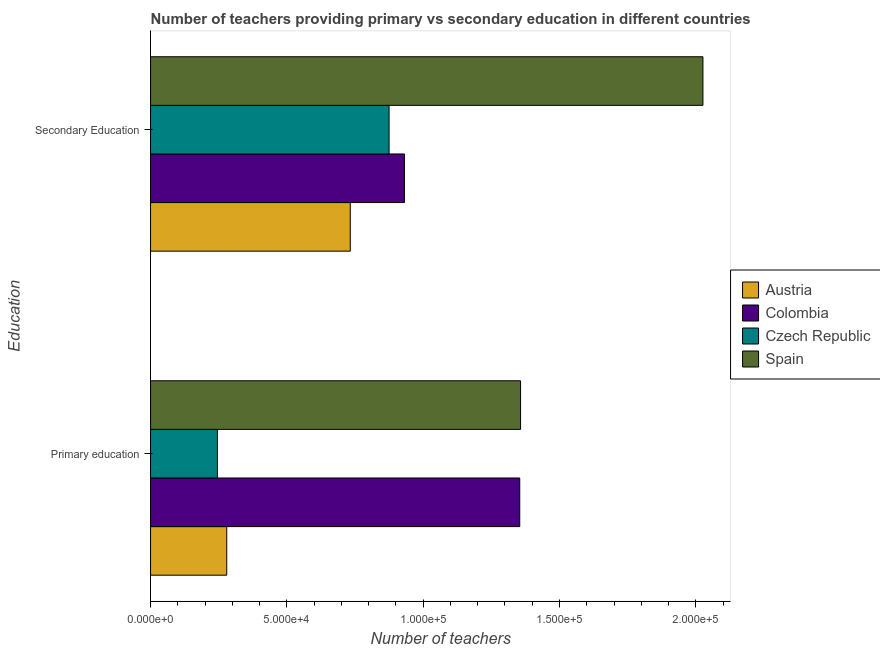How many different coloured bars are there?
Ensure brevity in your answer.  4. How many groups of bars are there?
Your answer should be very brief. 2. Are the number of bars on each tick of the Y-axis equal?
Your answer should be compact. Yes. How many bars are there on the 1st tick from the top?
Provide a succinct answer. 4. What is the number of primary teachers in Spain?
Your answer should be very brief. 1.36e+05. Across all countries, what is the maximum number of primary teachers?
Your answer should be compact. 1.36e+05. Across all countries, what is the minimum number of primary teachers?
Your response must be concise. 2.45e+04. In which country was the number of primary teachers maximum?
Keep it short and to the point. Spain. In which country was the number of secondary teachers minimum?
Offer a very short reply. Austria. What is the total number of secondary teachers in the graph?
Give a very brief answer. 4.56e+05. What is the difference between the number of secondary teachers in Spain and that in Czech Republic?
Ensure brevity in your answer.  1.15e+05. What is the difference between the number of primary teachers in Czech Republic and the number of secondary teachers in Spain?
Provide a succinct answer. -1.78e+05. What is the average number of secondary teachers per country?
Provide a succinct answer. 1.14e+05. What is the difference between the number of secondary teachers and number of primary teachers in Austria?
Ensure brevity in your answer.  4.53e+04. What is the ratio of the number of secondary teachers in Colombia to that in Spain?
Your answer should be very brief. 0.46. Is the number of primary teachers in Colombia less than that in Czech Republic?
Offer a terse response. No. What does the 2nd bar from the top in Secondary Education represents?
Your answer should be very brief. Czech Republic. Are all the bars in the graph horizontal?
Provide a succinct answer. Yes. Are the values on the major ticks of X-axis written in scientific E-notation?
Offer a terse response. Yes. Does the graph contain grids?
Keep it short and to the point. No. Where does the legend appear in the graph?
Your answer should be very brief. Center right. What is the title of the graph?
Provide a short and direct response. Number of teachers providing primary vs secondary education in different countries. Does "Mauritania" appear as one of the legend labels in the graph?
Offer a terse response. No. What is the label or title of the X-axis?
Provide a succinct answer. Number of teachers. What is the label or title of the Y-axis?
Offer a very short reply. Education. What is the Number of teachers in Austria in Primary education?
Your answer should be very brief. 2.79e+04. What is the Number of teachers of Colombia in Primary education?
Your response must be concise. 1.35e+05. What is the Number of teachers of Czech Republic in Primary education?
Make the answer very short. 2.45e+04. What is the Number of teachers in Spain in Primary education?
Ensure brevity in your answer.  1.36e+05. What is the Number of teachers of Austria in Secondary Education?
Ensure brevity in your answer.  7.33e+04. What is the Number of teachers in Colombia in Secondary Education?
Make the answer very short. 9.31e+04. What is the Number of teachers in Czech Republic in Secondary Education?
Your answer should be compact. 8.75e+04. What is the Number of teachers of Spain in Secondary Education?
Offer a very short reply. 2.03e+05. Across all Education, what is the maximum Number of teachers in Austria?
Your response must be concise. 7.33e+04. Across all Education, what is the maximum Number of teachers in Colombia?
Provide a succinct answer. 1.35e+05. Across all Education, what is the maximum Number of teachers of Czech Republic?
Your response must be concise. 8.75e+04. Across all Education, what is the maximum Number of teachers in Spain?
Keep it short and to the point. 2.03e+05. Across all Education, what is the minimum Number of teachers of Austria?
Offer a terse response. 2.79e+04. Across all Education, what is the minimum Number of teachers of Colombia?
Your response must be concise. 9.31e+04. Across all Education, what is the minimum Number of teachers in Czech Republic?
Your answer should be compact. 2.45e+04. Across all Education, what is the minimum Number of teachers in Spain?
Ensure brevity in your answer.  1.36e+05. What is the total Number of teachers in Austria in the graph?
Your response must be concise. 1.01e+05. What is the total Number of teachers in Colombia in the graph?
Ensure brevity in your answer.  2.29e+05. What is the total Number of teachers in Czech Republic in the graph?
Your answer should be compact. 1.12e+05. What is the total Number of teachers in Spain in the graph?
Provide a short and direct response. 3.38e+05. What is the difference between the Number of teachers in Austria in Primary education and that in Secondary Education?
Offer a terse response. -4.53e+04. What is the difference between the Number of teachers in Colombia in Primary education and that in Secondary Education?
Offer a terse response. 4.23e+04. What is the difference between the Number of teachers of Czech Republic in Primary education and that in Secondary Education?
Make the answer very short. -6.30e+04. What is the difference between the Number of teachers in Spain in Primary education and that in Secondary Education?
Your answer should be very brief. -6.69e+04. What is the difference between the Number of teachers of Austria in Primary education and the Number of teachers of Colombia in Secondary Education?
Ensure brevity in your answer.  -6.52e+04. What is the difference between the Number of teachers of Austria in Primary education and the Number of teachers of Czech Republic in Secondary Education?
Your answer should be very brief. -5.95e+04. What is the difference between the Number of teachers in Austria in Primary education and the Number of teachers in Spain in Secondary Education?
Your answer should be compact. -1.75e+05. What is the difference between the Number of teachers of Colombia in Primary education and the Number of teachers of Czech Republic in Secondary Education?
Provide a succinct answer. 4.79e+04. What is the difference between the Number of teachers in Colombia in Primary education and the Number of teachers in Spain in Secondary Education?
Provide a short and direct response. -6.72e+04. What is the difference between the Number of teachers of Czech Republic in Primary education and the Number of teachers of Spain in Secondary Education?
Your answer should be very brief. -1.78e+05. What is the average Number of teachers in Austria per Education?
Ensure brevity in your answer.  5.06e+04. What is the average Number of teachers of Colombia per Education?
Ensure brevity in your answer.  1.14e+05. What is the average Number of teachers of Czech Republic per Education?
Give a very brief answer. 5.60e+04. What is the average Number of teachers of Spain per Education?
Your answer should be compact. 1.69e+05. What is the difference between the Number of teachers of Austria and Number of teachers of Colombia in Primary education?
Your answer should be very brief. -1.07e+05. What is the difference between the Number of teachers of Austria and Number of teachers of Czech Republic in Primary education?
Your response must be concise. 3421. What is the difference between the Number of teachers of Austria and Number of teachers of Spain in Primary education?
Offer a very short reply. -1.08e+05. What is the difference between the Number of teachers in Colombia and Number of teachers in Czech Republic in Primary education?
Your answer should be compact. 1.11e+05. What is the difference between the Number of teachers in Colombia and Number of teachers in Spain in Primary education?
Your answer should be compact. -298. What is the difference between the Number of teachers of Czech Republic and Number of teachers of Spain in Primary education?
Make the answer very short. -1.11e+05. What is the difference between the Number of teachers in Austria and Number of teachers in Colombia in Secondary Education?
Ensure brevity in your answer.  -1.99e+04. What is the difference between the Number of teachers in Austria and Number of teachers in Czech Republic in Secondary Education?
Make the answer very short. -1.42e+04. What is the difference between the Number of teachers of Austria and Number of teachers of Spain in Secondary Education?
Keep it short and to the point. -1.29e+05. What is the difference between the Number of teachers in Colombia and Number of teachers in Czech Republic in Secondary Education?
Your response must be concise. 5633. What is the difference between the Number of teachers in Colombia and Number of teachers in Spain in Secondary Education?
Offer a terse response. -1.09e+05. What is the difference between the Number of teachers of Czech Republic and Number of teachers of Spain in Secondary Education?
Provide a short and direct response. -1.15e+05. What is the ratio of the Number of teachers in Austria in Primary education to that in Secondary Education?
Keep it short and to the point. 0.38. What is the ratio of the Number of teachers in Colombia in Primary education to that in Secondary Education?
Provide a succinct answer. 1.45. What is the ratio of the Number of teachers in Czech Republic in Primary education to that in Secondary Education?
Provide a short and direct response. 0.28. What is the ratio of the Number of teachers of Spain in Primary education to that in Secondary Education?
Make the answer very short. 0.67. What is the difference between the highest and the second highest Number of teachers in Austria?
Keep it short and to the point. 4.53e+04. What is the difference between the highest and the second highest Number of teachers in Colombia?
Offer a terse response. 4.23e+04. What is the difference between the highest and the second highest Number of teachers of Czech Republic?
Ensure brevity in your answer.  6.30e+04. What is the difference between the highest and the second highest Number of teachers of Spain?
Provide a short and direct response. 6.69e+04. What is the difference between the highest and the lowest Number of teachers of Austria?
Your answer should be compact. 4.53e+04. What is the difference between the highest and the lowest Number of teachers of Colombia?
Offer a very short reply. 4.23e+04. What is the difference between the highest and the lowest Number of teachers of Czech Republic?
Provide a short and direct response. 6.30e+04. What is the difference between the highest and the lowest Number of teachers of Spain?
Your answer should be compact. 6.69e+04. 